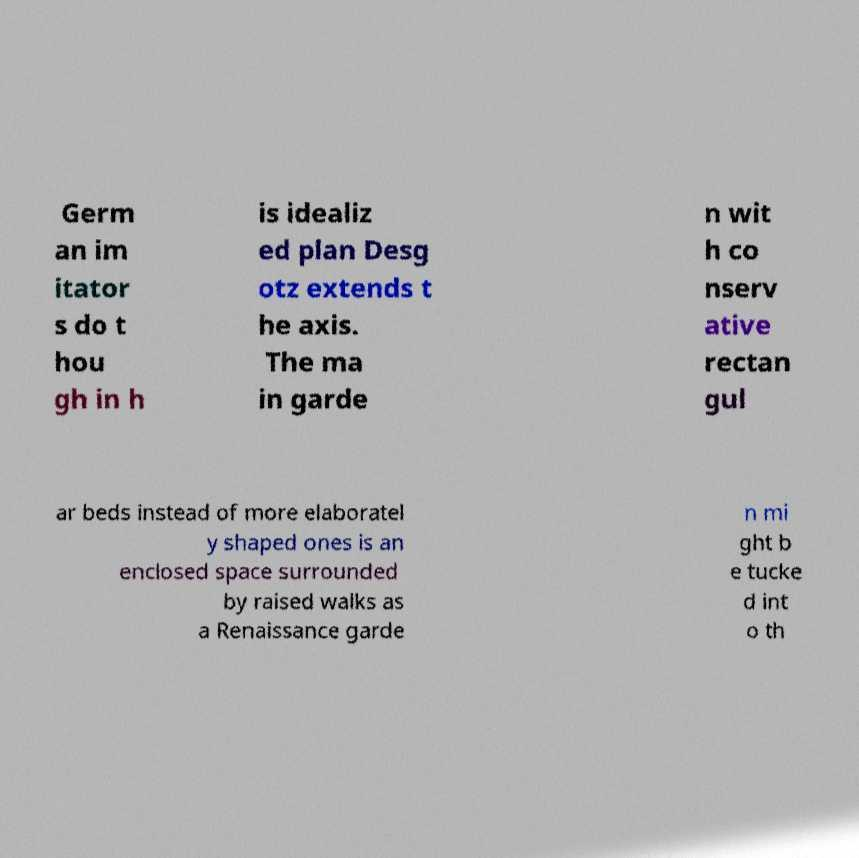What messages or text are displayed in this image? I need them in a readable, typed format. Germ an im itator s do t hou gh in h is idealiz ed plan Desg otz extends t he axis. The ma in garde n wit h co nserv ative rectan gul ar beds instead of more elaboratel y shaped ones is an enclosed space surrounded by raised walks as a Renaissance garde n mi ght b e tucke d int o th 